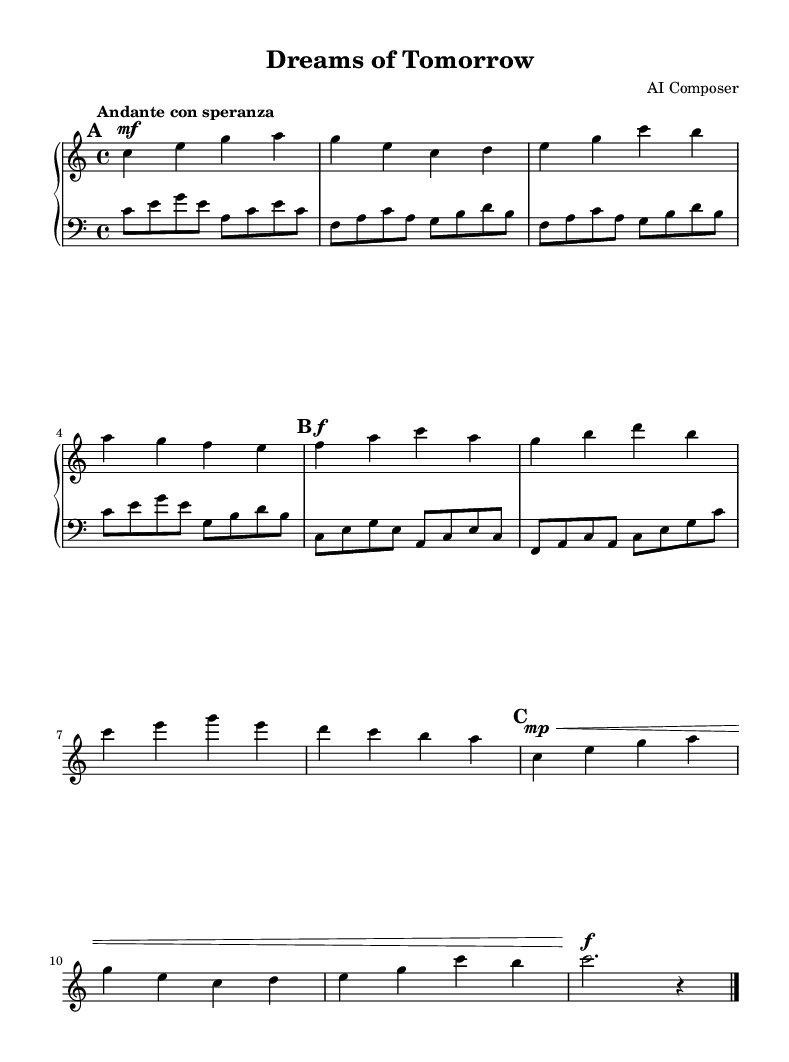What is the key signature of this music? The key signature shown in the music indicates C major, which has no sharps or flats. You can identify it by looking at the beginning of the staff for any sharps or flats.
Answer: C major What is the time signature of this piece? The time signature is displayed at the beginning of the score as 4/4. It indicates that there are four beats in each measure and a quarter note gets one beat.
Answer: 4/4 What is the tempo marking for this piece? The tempo marking reads "Andante con speranza," which indicates a moderate tempo with a hopeful feeling. It gives performers guidance on how fast or slow to play the music.
Answer: Andante con speranza How many measures are in the A section? The A section consists of four measures as indicated by the grouping of the notes and the repeated sections of music within those lines.
Answer: Four measures What are the dynamics of the A' section? The dynamics of the A' section start with a pianissimo marking (mp), indicating a soft volume, and then become forte (f) at the end. This shows a contrast in intensity within that section.
Answer: mp, f What is the highest note in the right hand? The highest note in the right hand is "a" in the first section. You can identify this by looking for the highest position of the notes on the staff in that part of the music.
Answer: a 